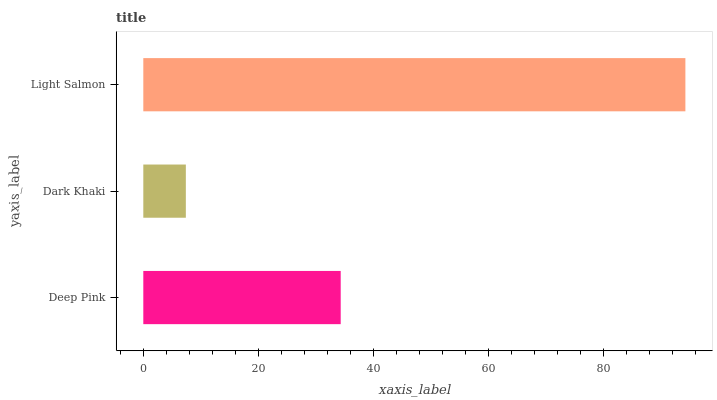Is Dark Khaki the minimum?
Answer yes or no. Yes. Is Light Salmon the maximum?
Answer yes or no. Yes. Is Light Salmon the minimum?
Answer yes or no. No. Is Dark Khaki the maximum?
Answer yes or no. No. Is Light Salmon greater than Dark Khaki?
Answer yes or no. Yes. Is Dark Khaki less than Light Salmon?
Answer yes or no. Yes. Is Dark Khaki greater than Light Salmon?
Answer yes or no. No. Is Light Salmon less than Dark Khaki?
Answer yes or no. No. Is Deep Pink the high median?
Answer yes or no. Yes. Is Deep Pink the low median?
Answer yes or no. Yes. Is Light Salmon the high median?
Answer yes or no. No. Is Dark Khaki the low median?
Answer yes or no. No. 